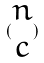<formula> <loc_0><loc_0><loc_500><loc_500>( \begin{matrix} n \\ c \end{matrix} )</formula> 